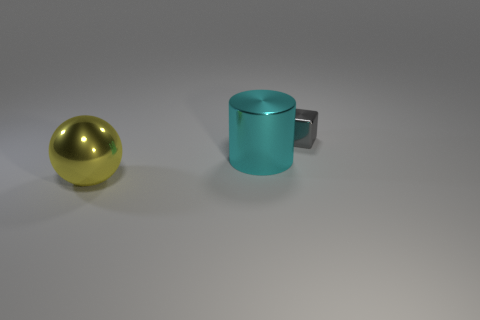Is there any other thing that is the same size as the metallic cube?
Offer a terse response. No. Is the number of tiny gray shiny cubes greater than the number of shiny things?
Provide a short and direct response. No. Does the large object on the right side of the ball have the same material as the ball?
Give a very brief answer. Yes. Are there fewer shiny cubes than large purple metallic balls?
Offer a very short reply. No. Are there any large metallic things on the right side of the object left of the big shiny thing behind the big yellow object?
Your answer should be compact. Yes. Are there more metallic balls that are left of the metal cylinder than gray metallic cylinders?
Give a very brief answer. Yes. What is the color of the large thing on the right side of the large object that is left of the large thing behind the large yellow metal object?
Provide a short and direct response. Cyan. Is the size of the gray metallic object the same as the cylinder?
Make the answer very short. No. How many metallic objects are the same size as the cyan cylinder?
Your answer should be compact. 1. Are there any other things that are the same shape as the tiny gray metal thing?
Ensure brevity in your answer.  No. 